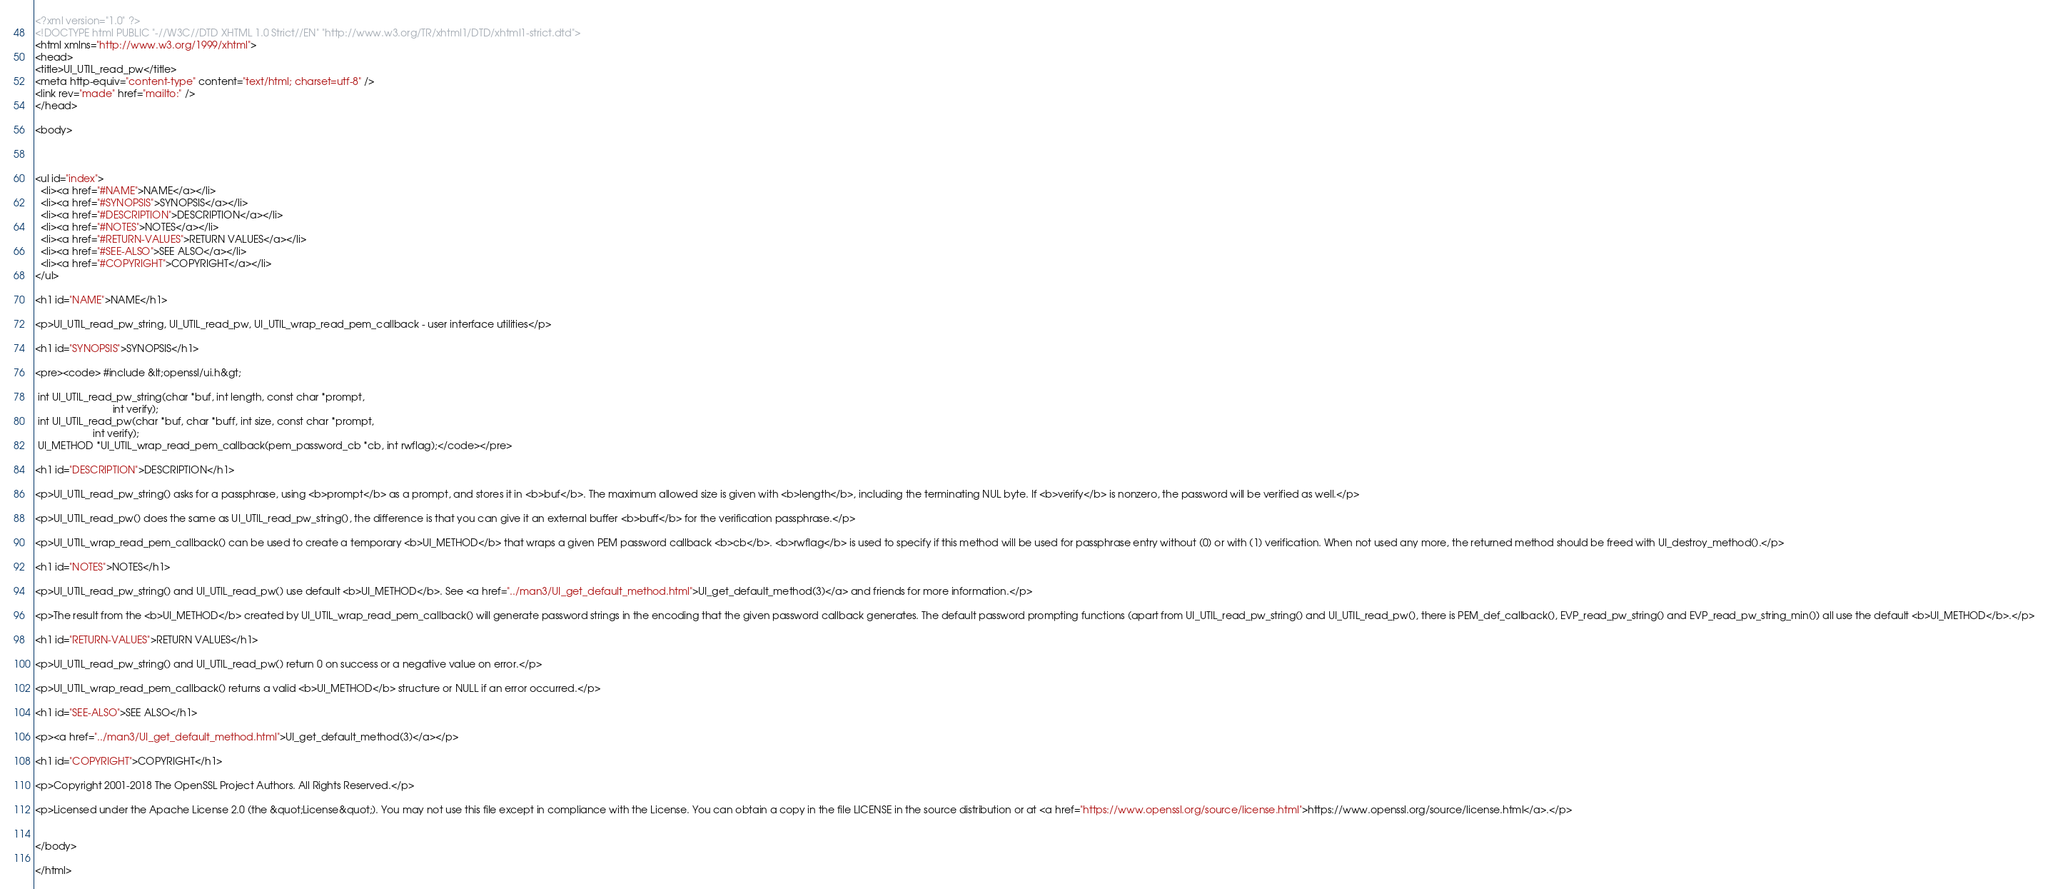Convert code to text. <code><loc_0><loc_0><loc_500><loc_500><_HTML_><?xml version="1.0" ?>
<!DOCTYPE html PUBLIC "-//W3C//DTD XHTML 1.0 Strict//EN" "http://www.w3.org/TR/xhtml1/DTD/xhtml1-strict.dtd">
<html xmlns="http://www.w3.org/1999/xhtml">
<head>
<title>UI_UTIL_read_pw</title>
<meta http-equiv="content-type" content="text/html; charset=utf-8" />
<link rev="made" href="mailto:" />
</head>

<body>



<ul id="index">
  <li><a href="#NAME">NAME</a></li>
  <li><a href="#SYNOPSIS">SYNOPSIS</a></li>
  <li><a href="#DESCRIPTION">DESCRIPTION</a></li>
  <li><a href="#NOTES">NOTES</a></li>
  <li><a href="#RETURN-VALUES">RETURN VALUES</a></li>
  <li><a href="#SEE-ALSO">SEE ALSO</a></li>
  <li><a href="#COPYRIGHT">COPYRIGHT</a></li>
</ul>

<h1 id="NAME">NAME</h1>

<p>UI_UTIL_read_pw_string, UI_UTIL_read_pw, UI_UTIL_wrap_read_pem_callback - user interface utilities</p>

<h1 id="SYNOPSIS">SYNOPSIS</h1>

<pre><code> #include &lt;openssl/ui.h&gt;

 int UI_UTIL_read_pw_string(char *buf, int length, const char *prompt,
                            int verify);
 int UI_UTIL_read_pw(char *buf, char *buff, int size, const char *prompt,
                     int verify);
 UI_METHOD *UI_UTIL_wrap_read_pem_callback(pem_password_cb *cb, int rwflag);</code></pre>

<h1 id="DESCRIPTION">DESCRIPTION</h1>

<p>UI_UTIL_read_pw_string() asks for a passphrase, using <b>prompt</b> as a prompt, and stores it in <b>buf</b>. The maximum allowed size is given with <b>length</b>, including the terminating NUL byte. If <b>verify</b> is nonzero, the password will be verified as well.</p>

<p>UI_UTIL_read_pw() does the same as UI_UTIL_read_pw_string(), the difference is that you can give it an external buffer <b>buff</b> for the verification passphrase.</p>

<p>UI_UTIL_wrap_read_pem_callback() can be used to create a temporary <b>UI_METHOD</b> that wraps a given PEM password callback <b>cb</b>. <b>rwflag</b> is used to specify if this method will be used for passphrase entry without (0) or with (1) verification. When not used any more, the returned method should be freed with UI_destroy_method().</p>

<h1 id="NOTES">NOTES</h1>

<p>UI_UTIL_read_pw_string() and UI_UTIL_read_pw() use default <b>UI_METHOD</b>. See <a href="../man3/UI_get_default_method.html">UI_get_default_method(3)</a> and friends for more information.</p>

<p>The result from the <b>UI_METHOD</b> created by UI_UTIL_wrap_read_pem_callback() will generate password strings in the encoding that the given password callback generates. The default password prompting functions (apart from UI_UTIL_read_pw_string() and UI_UTIL_read_pw(), there is PEM_def_callback(), EVP_read_pw_string() and EVP_read_pw_string_min()) all use the default <b>UI_METHOD</b>.</p>

<h1 id="RETURN-VALUES">RETURN VALUES</h1>

<p>UI_UTIL_read_pw_string() and UI_UTIL_read_pw() return 0 on success or a negative value on error.</p>

<p>UI_UTIL_wrap_read_pem_callback() returns a valid <b>UI_METHOD</b> structure or NULL if an error occurred.</p>

<h1 id="SEE-ALSO">SEE ALSO</h1>

<p><a href="../man3/UI_get_default_method.html">UI_get_default_method(3)</a></p>

<h1 id="COPYRIGHT">COPYRIGHT</h1>

<p>Copyright 2001-2018 The OpenSSL Project Authors. All Rights Reserved.</p>

<p>Licensed under the Apache License 2.0 (the &quot;License&quot;). You may not use this file except in compliance with the License. You can obtain a copy in the file LICENSE in the source distribution or at <a href="https://www.openssl.org/source/license.html">https://www.openssl.org/source/license.html</a>.</p>


</body>

</html>


</code> 